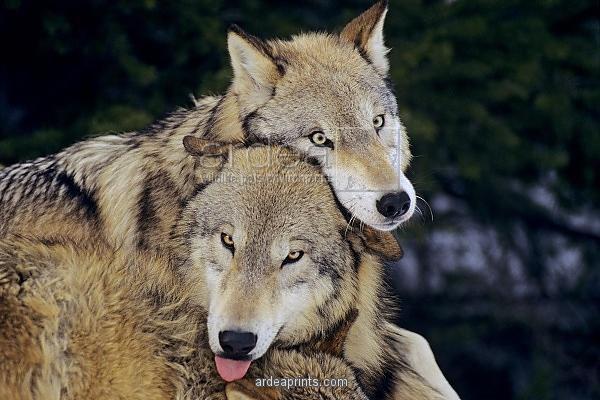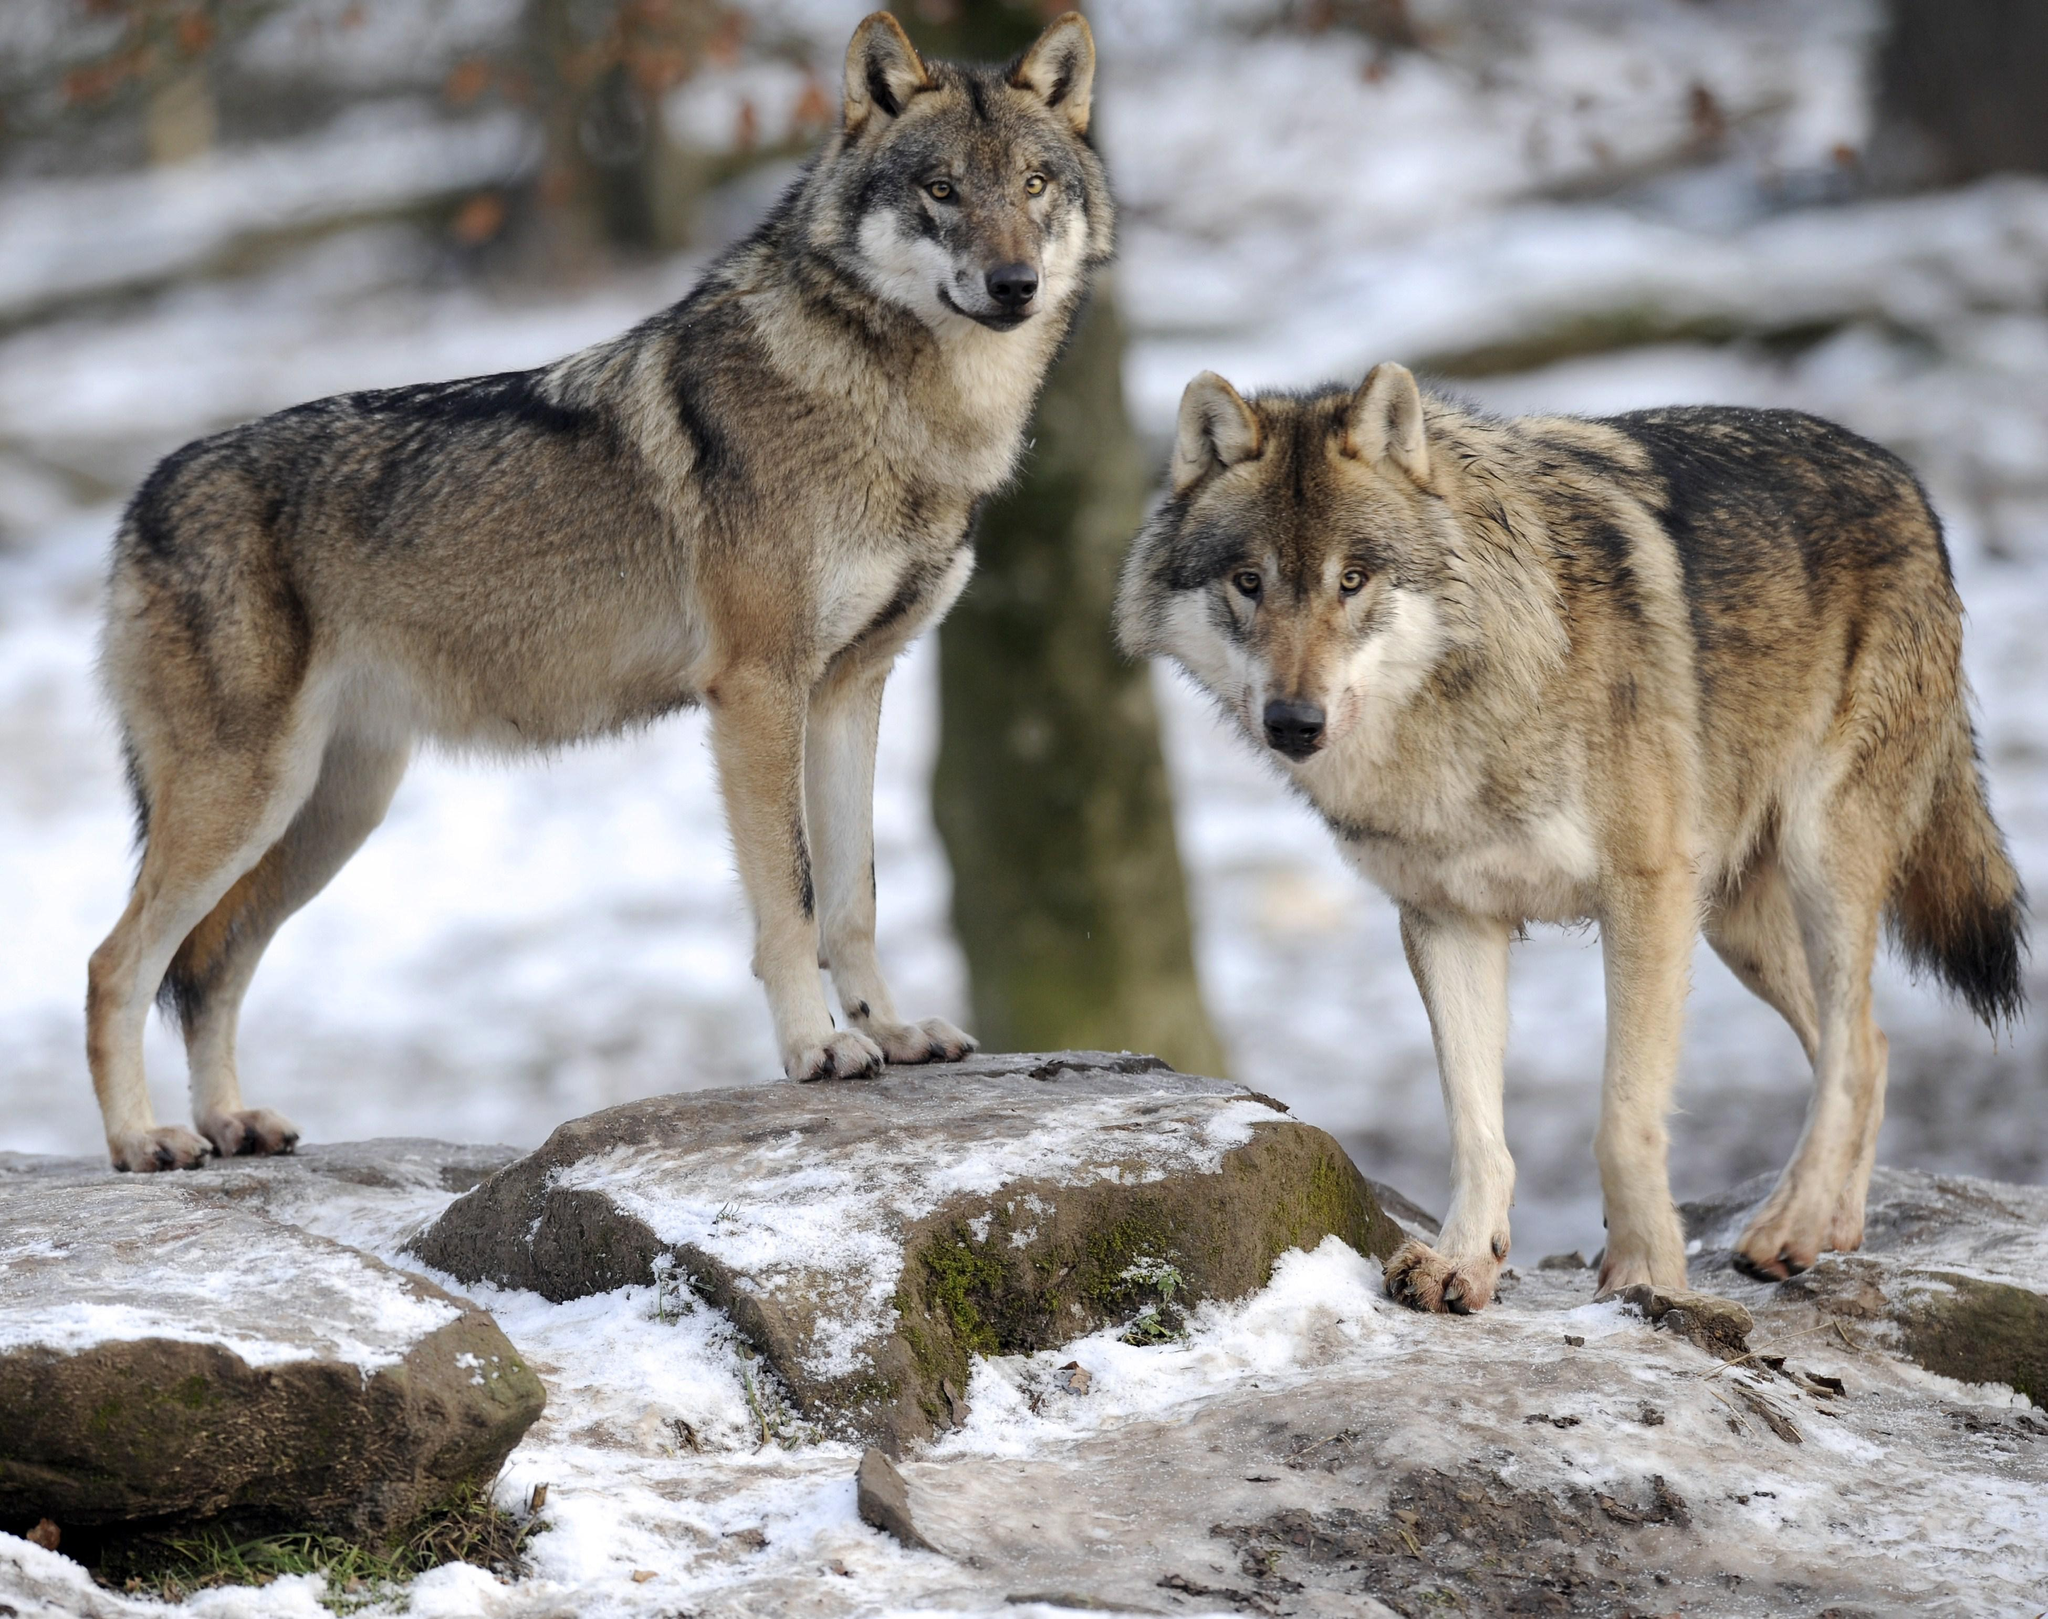The first image is the image on the left, the second image is the image on the right. Given the left and right images, does the statement "An image shows two non-standing wolves with heads nuzzling close together." hold true? Answer yes or no. Yes. The first image is the image on the left, the second image is the image on the right. Given the left and right images, does the statement "a pair of wolves are cuddling with faces close" hold true? Answer yes or no. Yes. 